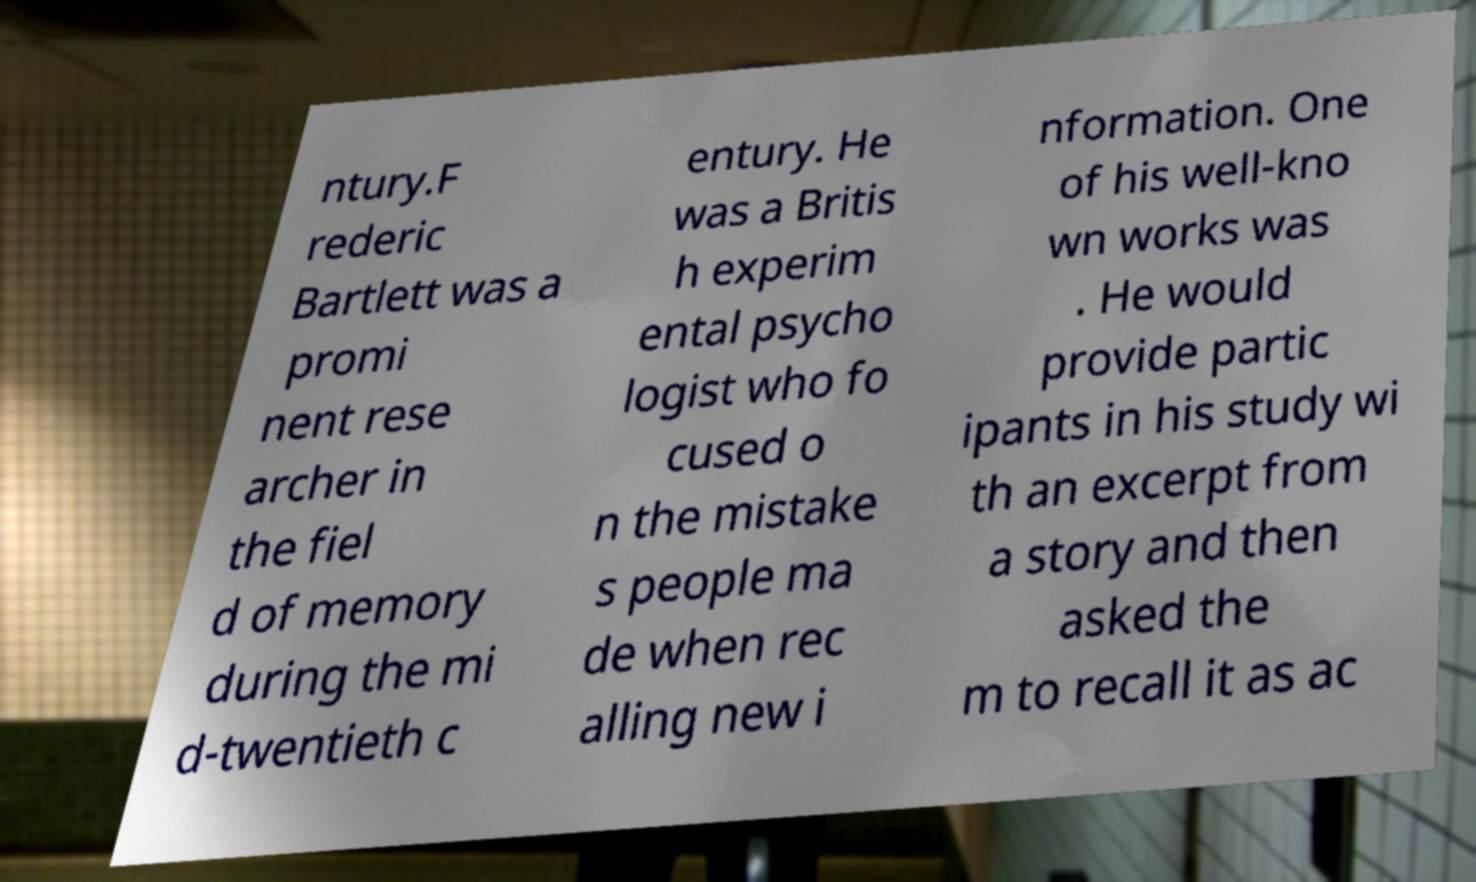Please identify and transcribe the text found in this image. ntury.F rederic Bartlett was a promi nent rese archer in the fiel d of memory during the mi d-twentieth c entury. He was a Britis h experim ental psycho logist who fo cused o n the mistake s people ma de when rec alling new i nformation. One of his well-kno wn works was . He would provide partic ipants in his study wi th an excerpt from a story and then asked the m to recall it as ac 